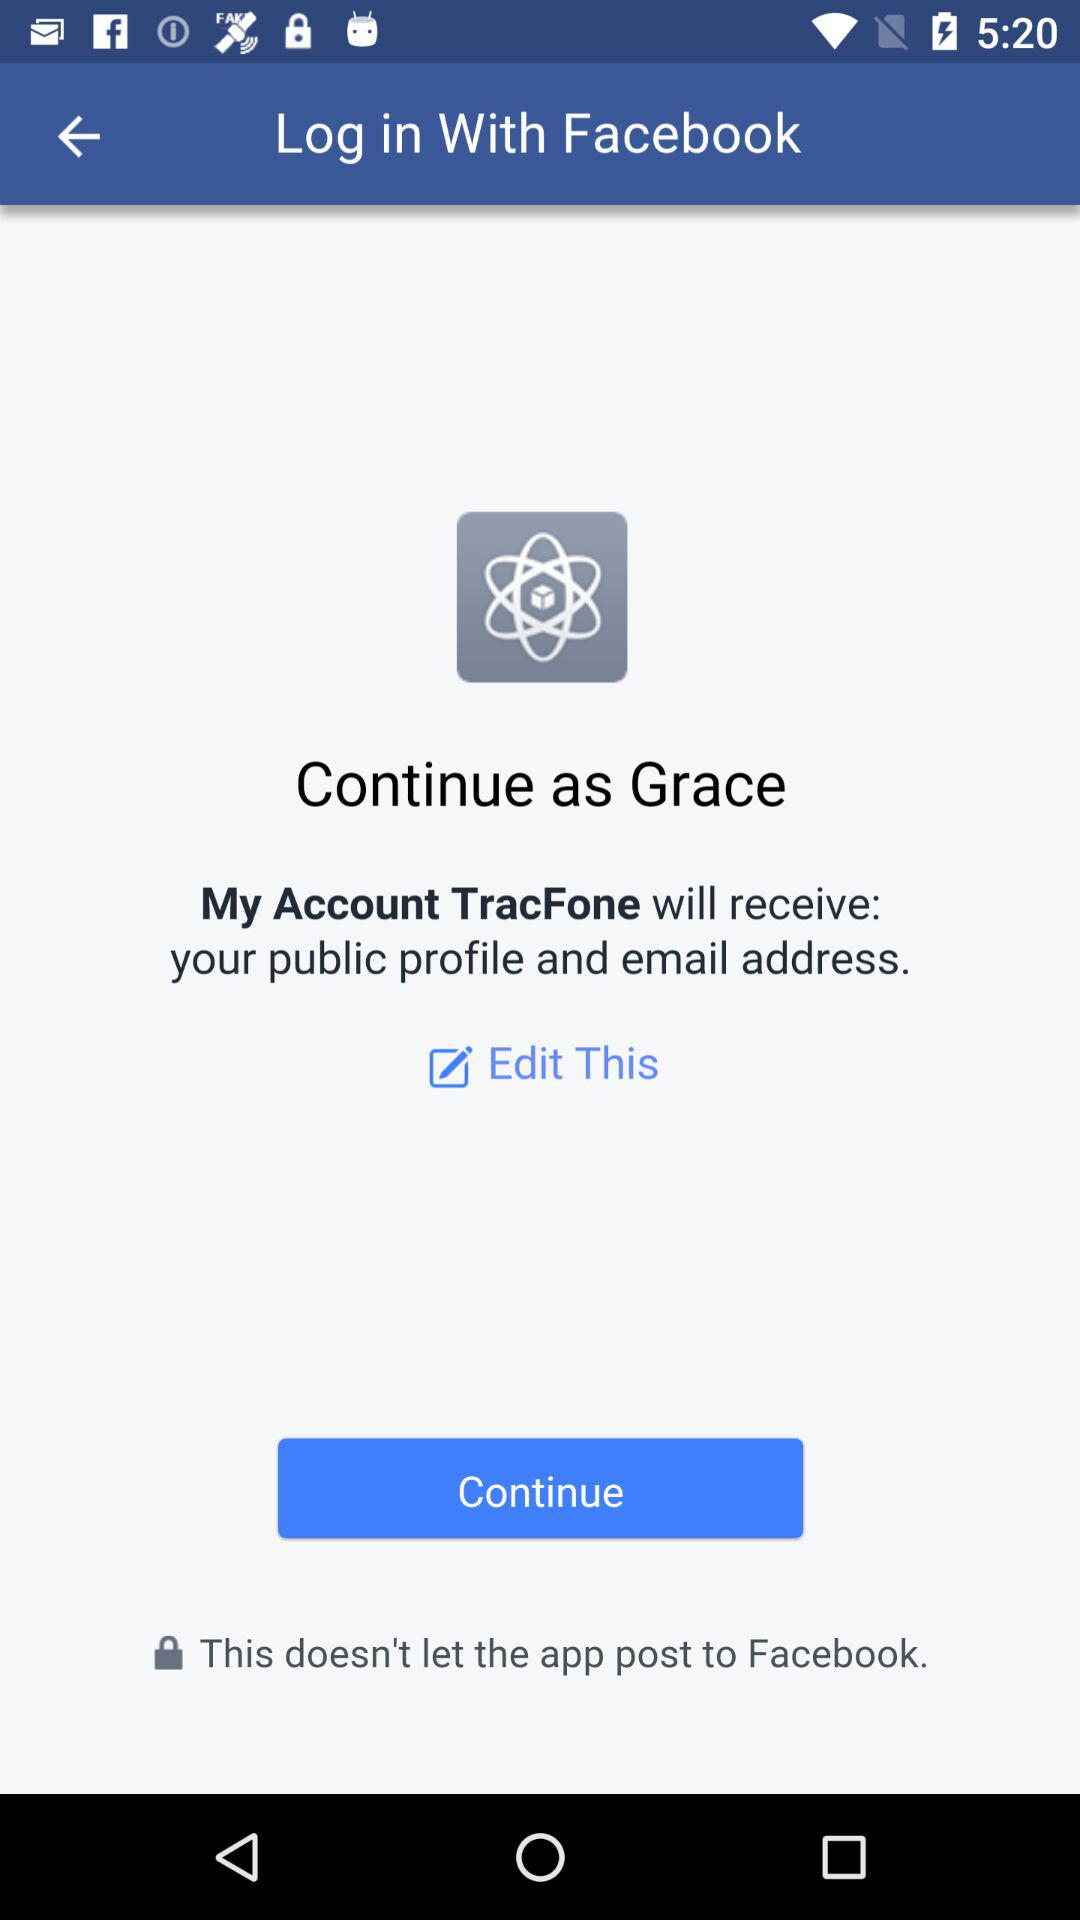What application will receive the public profile and email address? The application that will receive the public profile and email address is "My Account TracFone". 